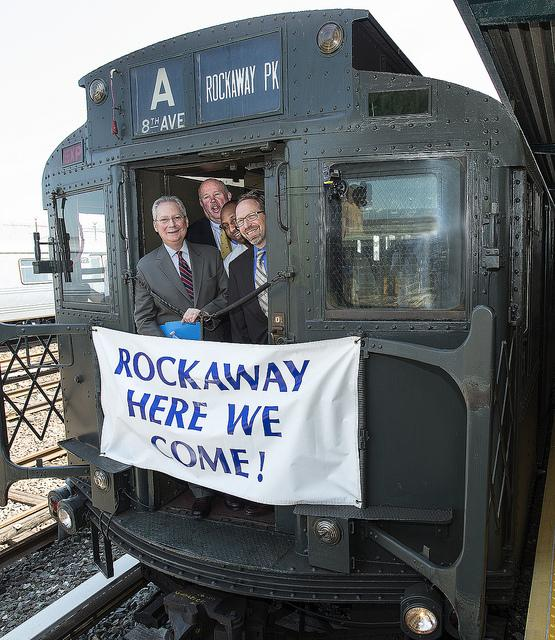Where is this train heading?

Choices:
A) 8th avenue
B) central pk
C) rockaway
D) pike ave rockaway 